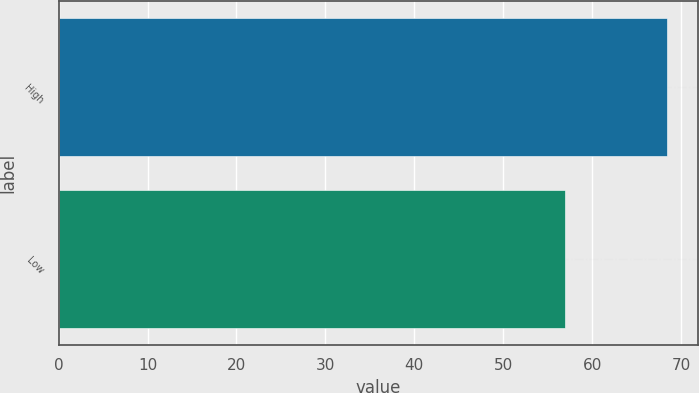<chart> <loc_0><loc_0><loc_500><loc_500><bar_chart><fcel>High<fcel>Low<nl><fcel>68.45<fcel>56.95<nl></chart> 